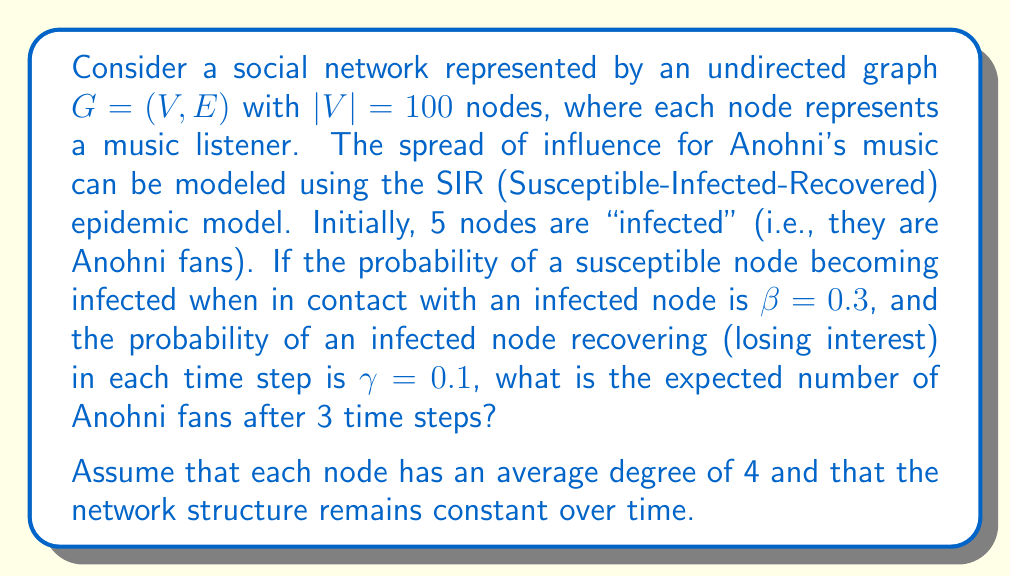Help me with this question. To solve this problem, we'll use the SIR model applied to the given network:

1) First, let's define our initial conditions:
   - Total population: $N = 100$
   - Initially infected: $I_0 = 5$
   - Initially susceptible: $S_0 = 95$
   - Initially recovered: $R_0 = 0$

2) We'll use the following discrete-time SIR equations:

   $$S_{t+1} = S_t - \beta \cdot \frac{S_t \cdot I_t \cdot \bar{k}}{N}$$
   $$I_{t+1} = I_t + \beta \cdot \frac{S_t \cdot I_t \cdot \bar{k}}{N} - \gamma \cdot I_t$$
   $$R_{t+1} = R_t + \gamma \cdot I_t$$

   Where $\bar{k}$ is the average degree (4 in this case).

3) Let's calculate for each time step:

   Time step 1:
   $$S_1 = 95 - 0.3 \cdot \frac{95 \cdot 5 \cdot 4}{100} = 89.3$$
   $$I_1 = 5 + 0.3 \cdot \frac{95 \cdot 5 \cdot 4}{100} - 0.1 \cdot 5 = 10.2$$
   $$R_1 = 0 + 0.1 \cdot 5 = 0.5$$

   Time step 2:
   $$S_2 = 89.3 - 0.3 \cdot \frac{89.3 \cdot 10.2 \cdot 4}{100} = 78.4$$
   $$I_2 = 10.2 + 0.3 \cdot \frac{89.3 \cdot 10.2 \cdot 4}{100} - 0.1 \cdot 10.2 = 19.9$$
   $$R_2 = 0.5 + 0.1 \cdot 10.2 = 1.7$$

   Time step 3:
   $$S_3 = 78.4 - 0.3 \cdot \frac{78.4 \cdot 19.9 \cdot 4}{100} = 59.7$$
   $$I_3 = 19.9 + 0.3 \cdot \frac{78.4 \cdot 19.9 \cdot 4}{100} - 0.1 \cdot 19.9 = 36.5$$
   $$R_3 = 1.7 + 0.1 \cdot 19.9 = 3.8$$

4) The number of Anohni fans after 3 time steps is represented by $I_3$, which is approximately 36.5.
Answer: The expected number of Anohni fans after 3 time steps is approximately 37 (rounded to the nearest whole number). 